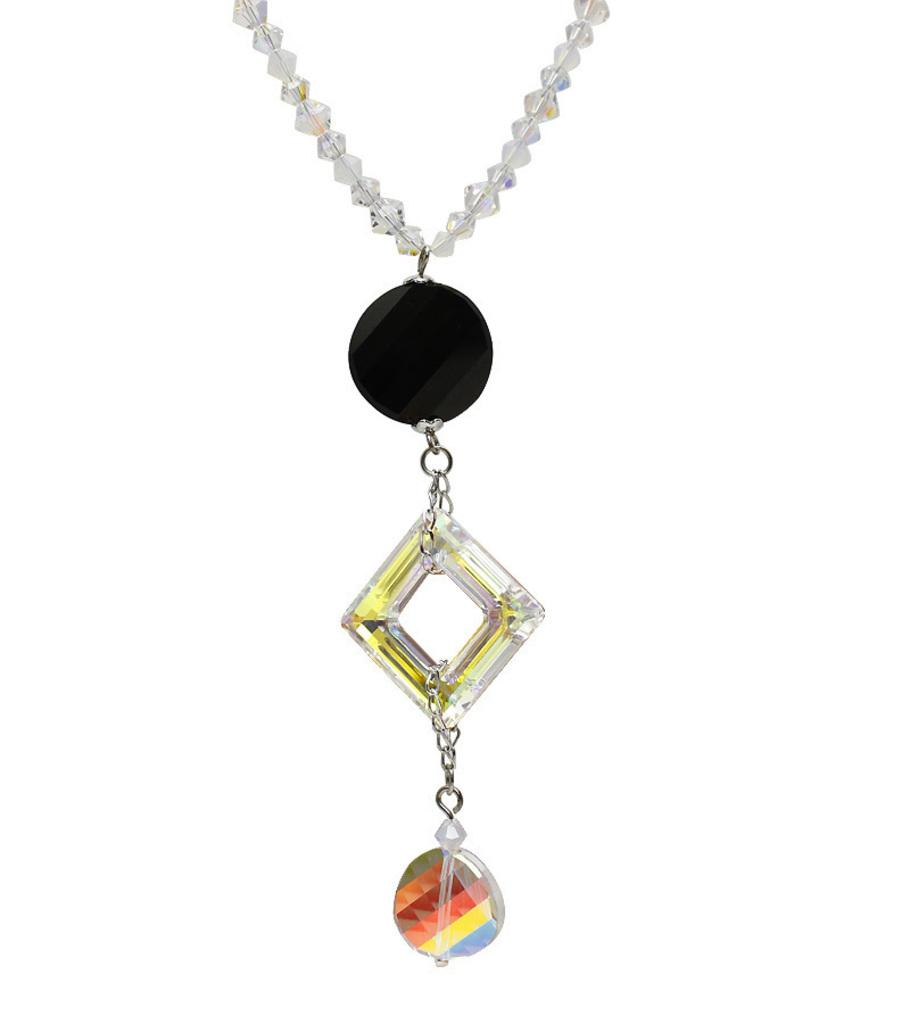What type of accessory is in the image? There is a necklace in the image. What colors can be seen on the objects attached to the necklace? There is a black color object and a multi-colored object attached to the necklace. What shapes can be seen on the objects attached to the necklace? There is a square object attached to the necklace. How are the objects connected to each other on the necklace? The objects are connected by a chain. What type of bean is visible in the image? There is no bean present in the image. What color is the sky in the image? The image does not show the sky, so it cannot be determined what color it is. 